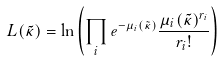Convert formula to latex. <formula><loc_0><loc_0><loc_500><loc_500>L ( \tilde { \kappa } ) = \ln \left ( \prod _ { i } e ^ { - \mu _ { i } ( \tilde { \kappa } ) } \frac { \mu _ { i } ( \tilde { \kappa } ) ^ { r _ { i } } } { r _ { i } ! } \right )</formula> 